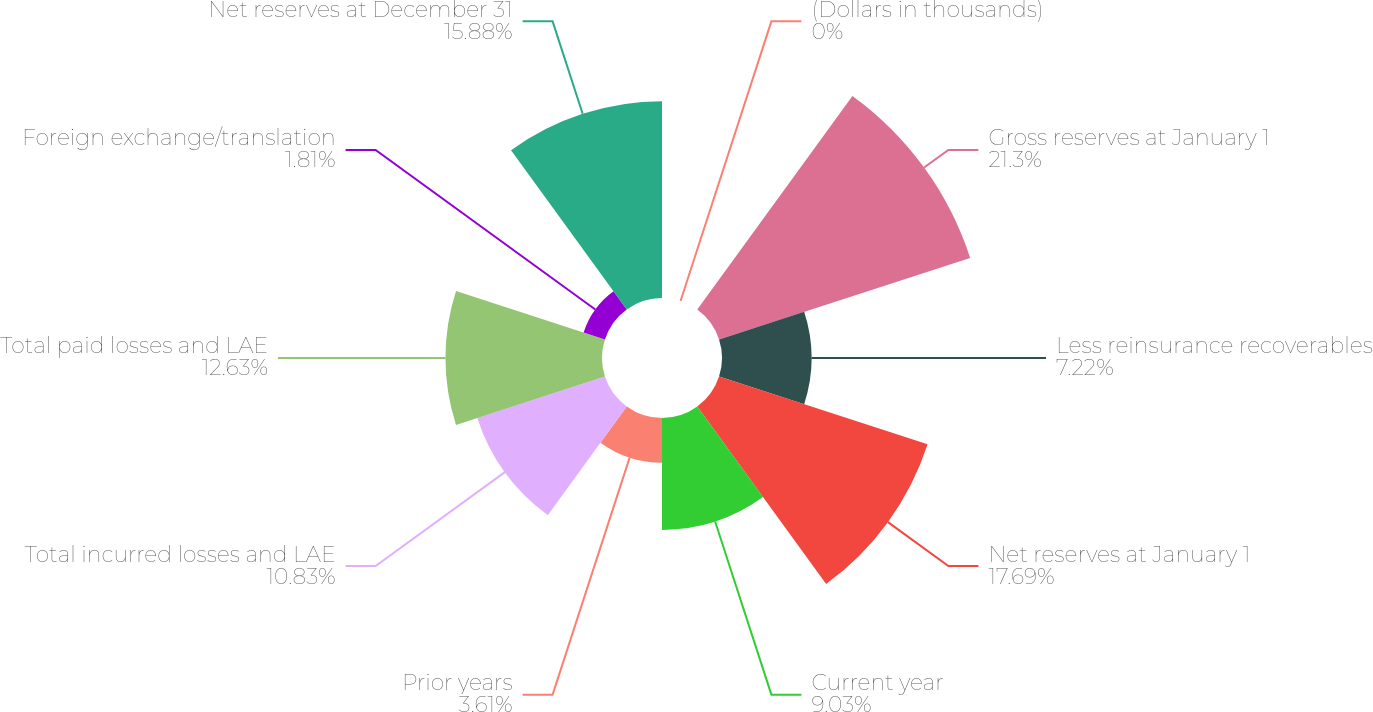Convert chart to OTSL. <chart><loc_0><loc_0><loc_500><loc_500><pie_chart><fcel>(Dollars in thousands)<fcel>Gross reserves at January 1<fcel>Less reinsurance recoverables<fcel>Net reserves at January 1<fcel>Current year<fcel>Prior years<fcel>Total incurred losses and LAE<fcel>Total paid losses and LAE<fcel>Foreign exchange/translation<fcel>Net reserves at December 31<nl><fcel>0.0%<fcel>21.3%<fcel>7.22%<fcel>17.69%<fcel>9.03%<fcel>3.61%<fcel>10.83%<fcel>12.63%<fcel>1.81%<fcel>15.88%<nl></chart> 